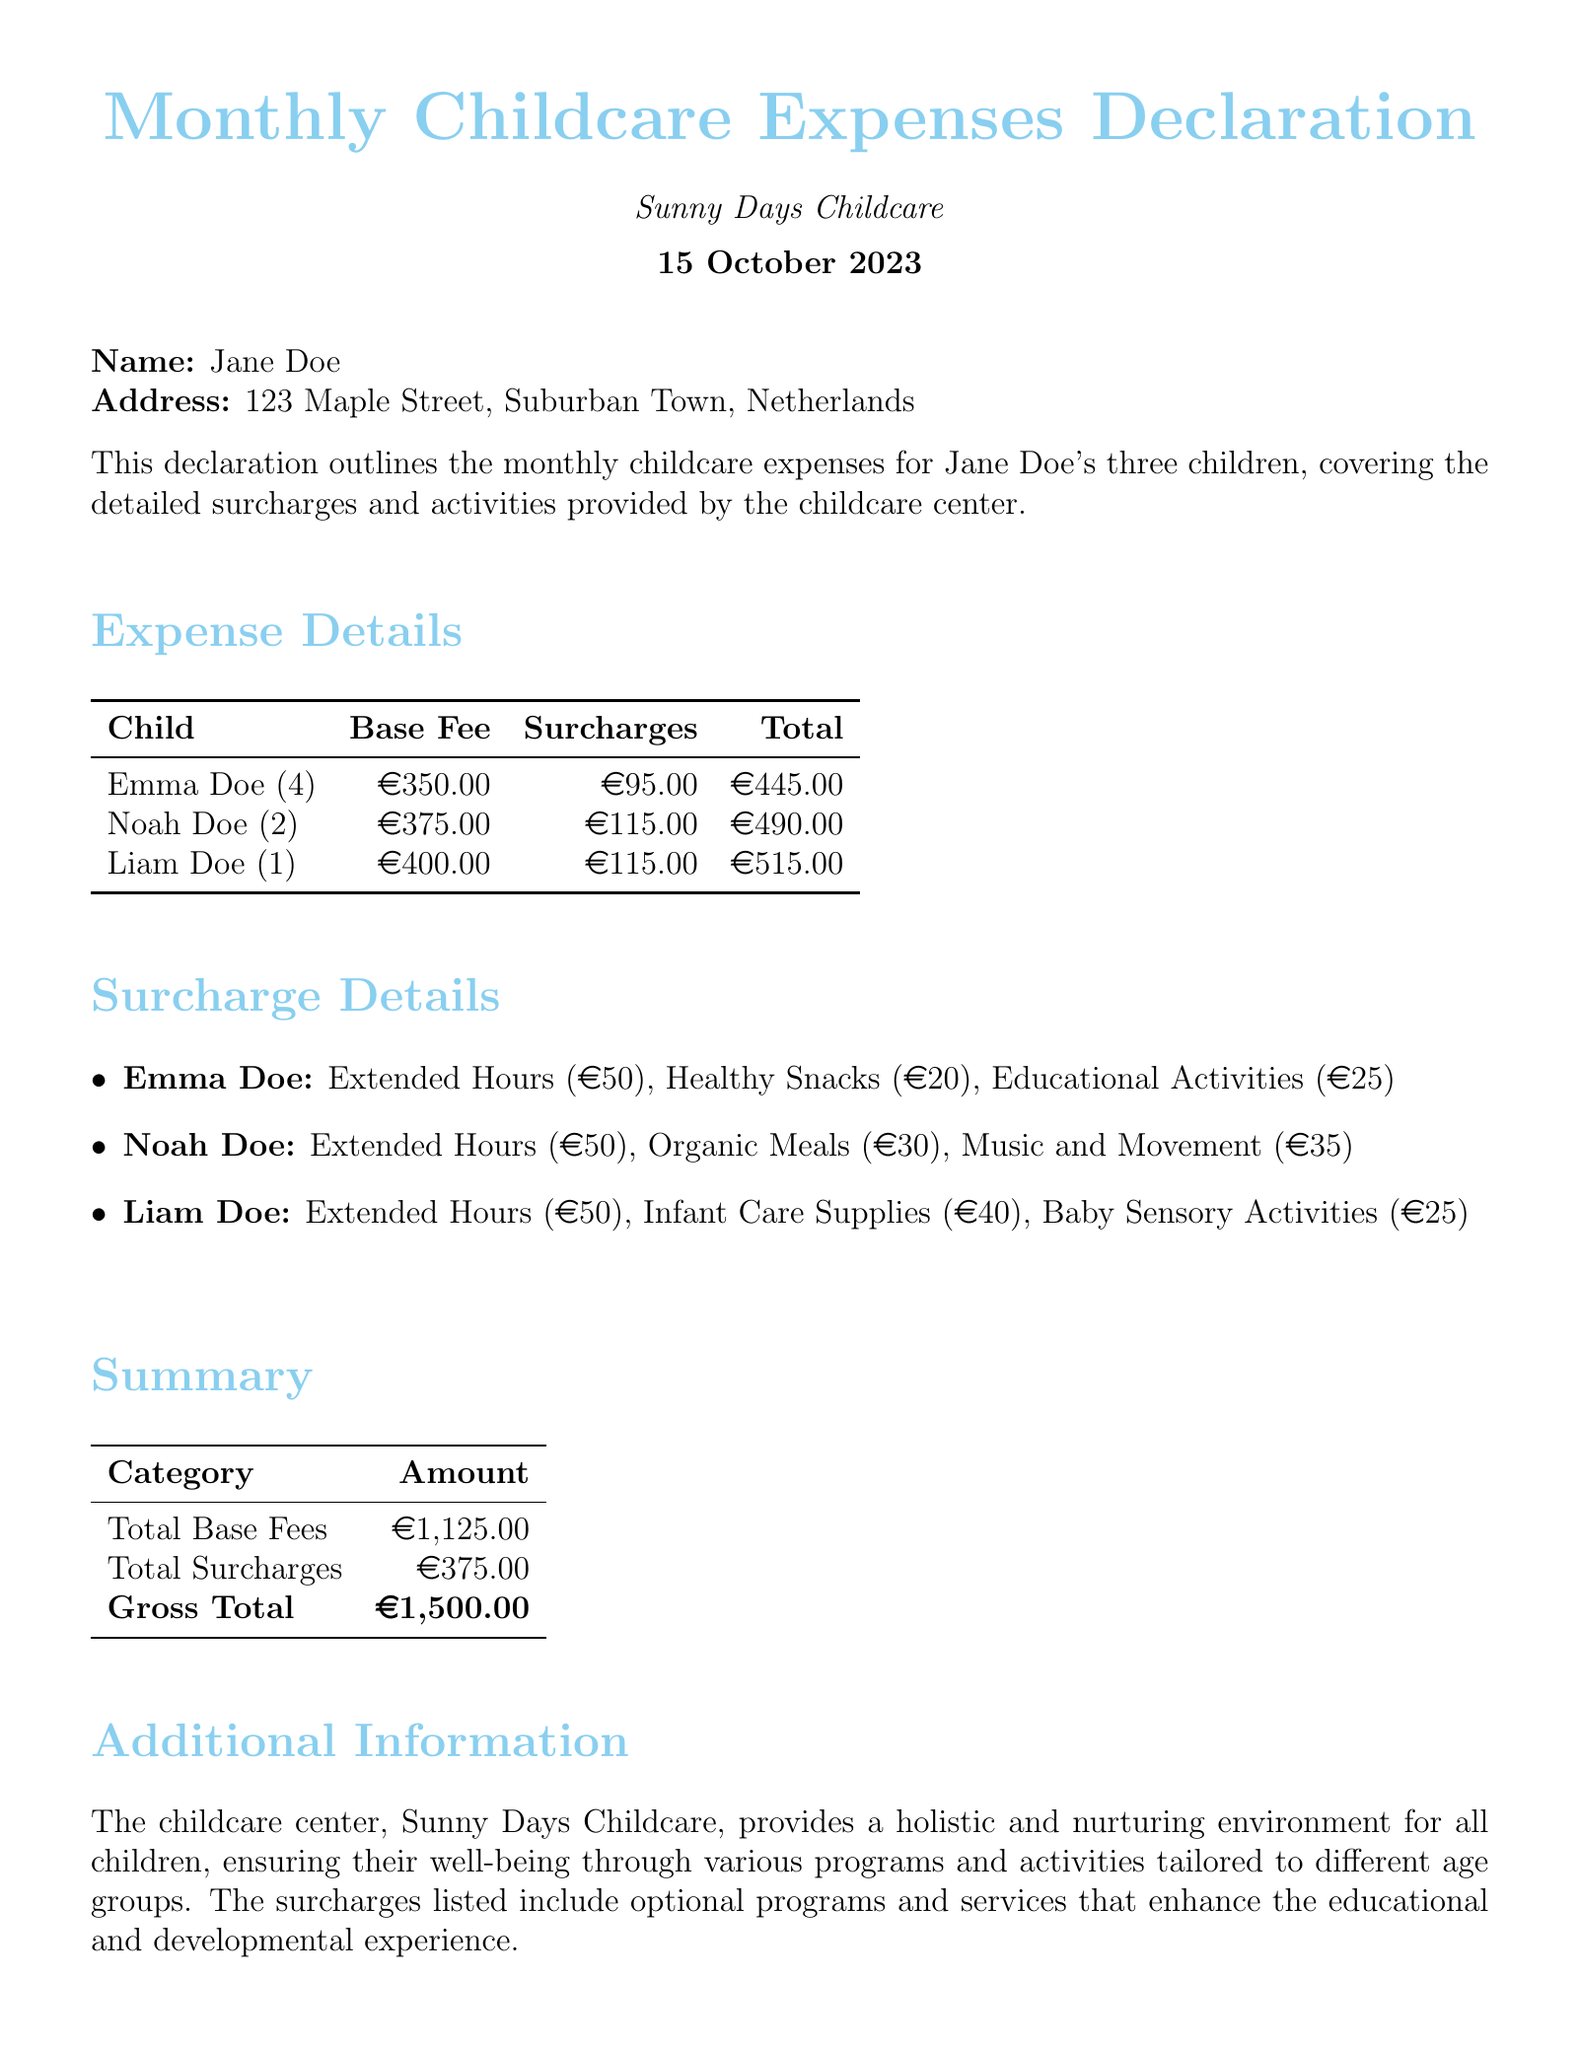What is the base fee for Emma Doe? The base fee for Emma Doe is listed under the Expense Details section.
Answer: €350.00 What are the total surcharges for Noah Doe? The total surcharges for Noah Doe include several surcharges listed in the Surcharge Details section.
Answer: €115.00 What is the gross total for all children’s expenses? The gross total is the final amount calculated in the Summary section, which combines base fees and surcharges.
Answer: €1,500.00 What additional activity is included for Liam Doe? An additional activity listed for Liam Doe is found in the Surcharge Details section.
Answer: Baby Sensory Activities How many children are declared in this document? The number of children can be counted from the Expense Details section.
Answer: Three What is the total amount of base fees? The total amount of base fees is provided in the Summary section as a cumulative total.
Answer: €1,125.00 What is the surcharge for healthy snacks for Emma Doe? The surcharge for healthy snacks is specified in the Surcharge Details section under Emma Doe's activities.
Answer: €20 Which childcare center is mentioned in the document? The childcare center's name is stated at the beginning of the document.
Answer: Sunny Days Childcare What date is this declaration made? The date of the declaration can be found at the top of the document, indicating when it was issued.
Answer: 15 October 2023 